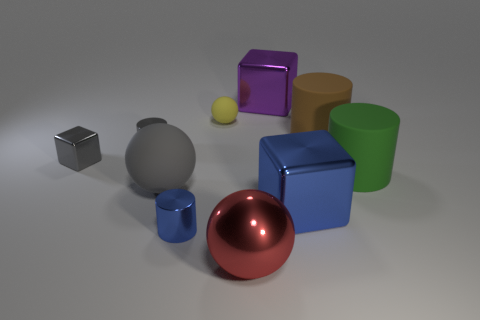There is a green thing that is made of the same material as the gray ball; what shape is it? The green object shares the reflective material characteristic of the gray ball and has a cylindrical shape, which is characterized by its circular base and parallel curved sides, extending vertically. 